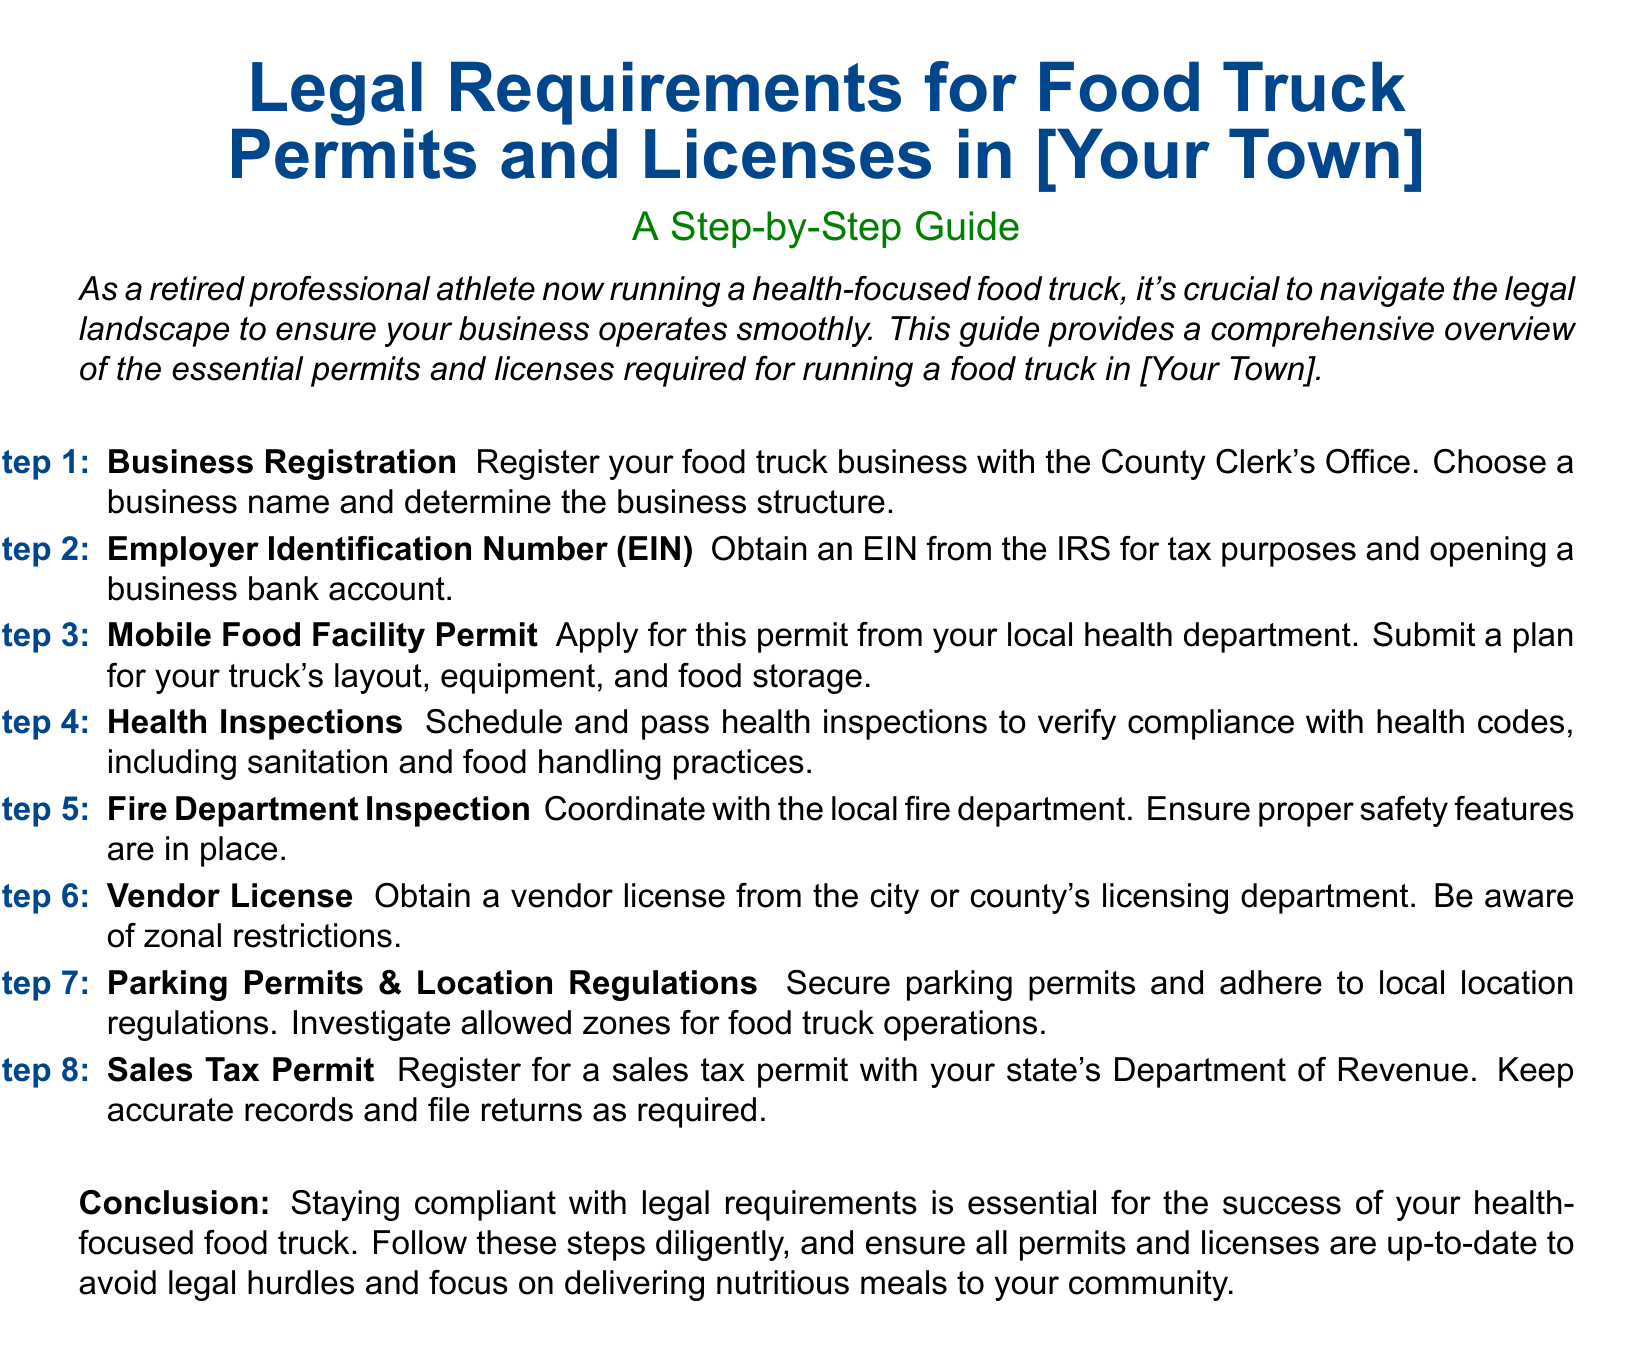What is the first step for obtaining a food truck permit? The first step outlined in the document is to register your food truck business with the County Clerk's Office.
Answer: Business Registration Which department issues the Mobile Food Facility Permit? The Mobile Food Facility Permit is issued by your local health department.
Answer: Local health department How many steps are listed in the guide for obtaining food truck permits? There are a total of eight steps listed in the guide for obtaining food truck permits.
Answer: Eight What is required for obtaining an EIN? An EIN is required for tax purposes and opening a business bank account.
Answer: Tax purposes and opening a business bank account What type of inspection must be scheduled for health compliance? The type of inspection that must be scheduled is a health inspection to verify compliance with health codes.
Answer: Health inspection Who coordinates the fire department inspection? The fire department inspection is coordinated with the local fire department.
Answer: Local fire department What should you secure for food truck operations according to the guide? You should secure parking permits for food truck operations.
Answer: Parking permits Which department do you register for a sales tax permit? You register for a sales tax permit with your state's Department of Revenue.
Answer: State's Department of Revenue 